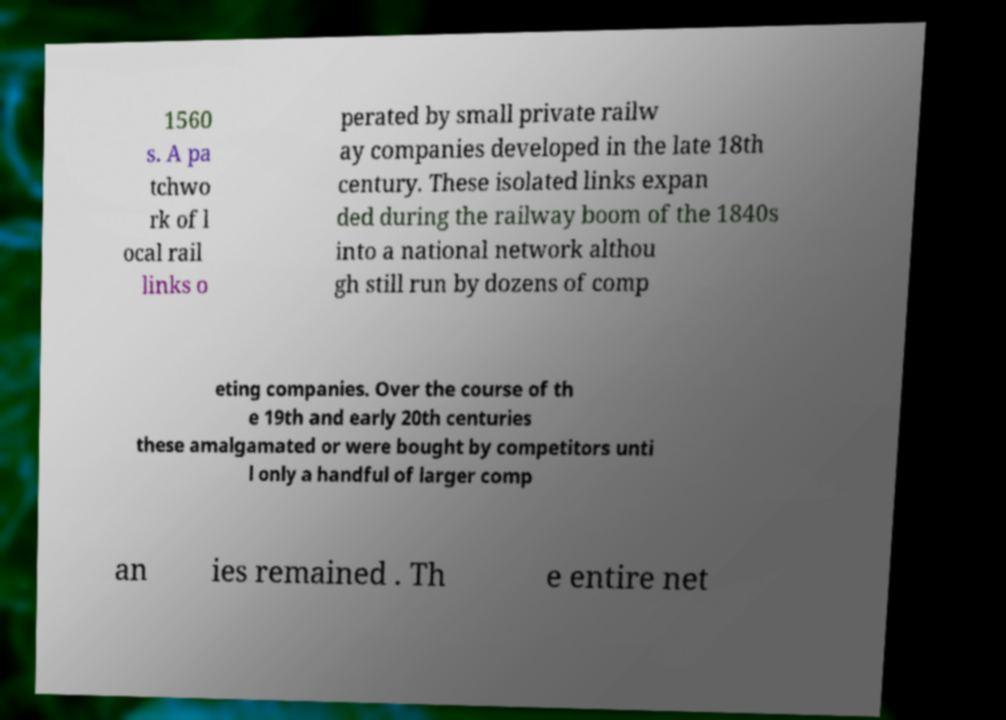For documentation purposes, I need the text within this image transcribed. Could you provide that? 1560 s. A pa tchwo rk of l ocal rail links o perated by small private railw ay companies developed in the late 18th century. These isolated links expan ded during the railway boom of the 1840s into a national network althou gh still run by dozens of comp eting companies. Over the course of th e 19th and early 20th centuries these amalgamated or were bought by competitors unti l only a handful of larger comp an ies remained . Th e entire net 